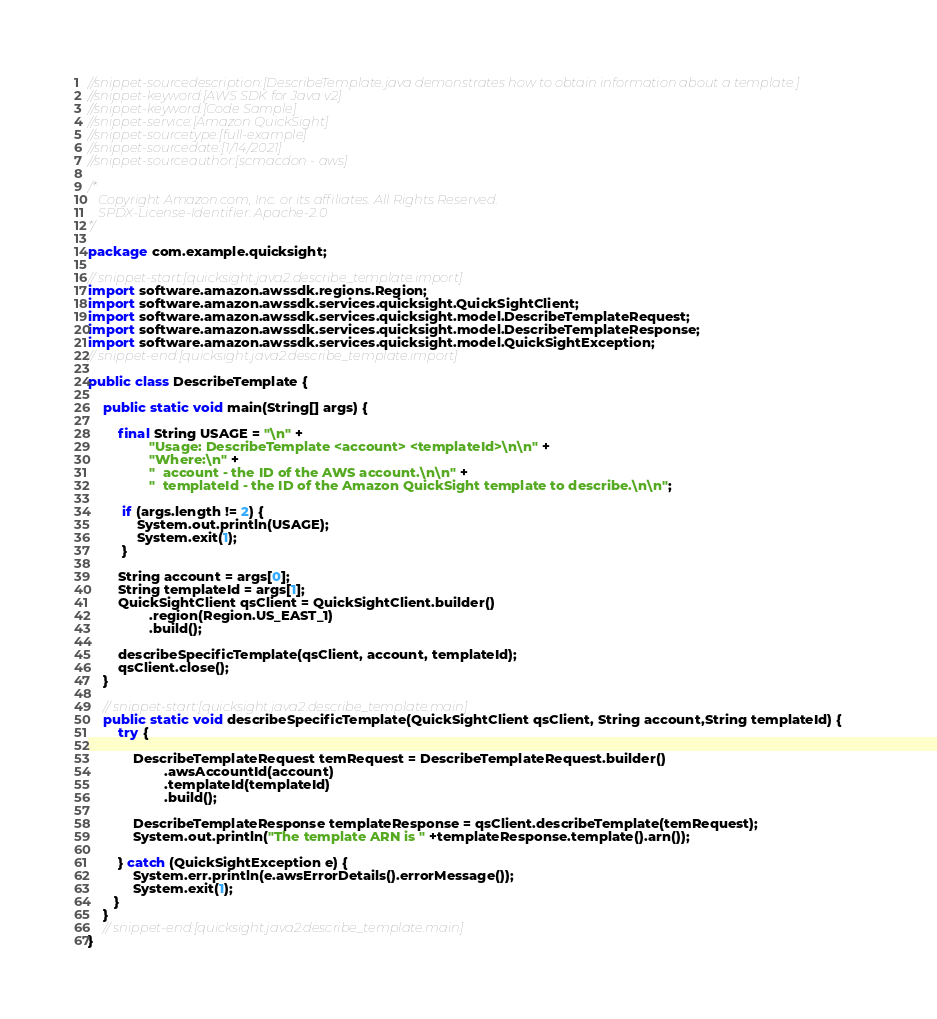<code> <loc_0><loc_0><loc_500><loc_500><_Java_>//snippet-sourcedescription:[DescribeTemplate.java demonstrates how to obtain information about a template.]
//snippet-keyword:[AWS SDK for Java v2]
//snippet-keyword:[Code Sample]
//snippet-service:[Amazon QuickSight]
//snippet-sourcetype:[full-example]
//snippet-sourcedate:[1/14/2021]
//snippet-sourceauthor:[scmacdon - aws]

/*
   Copyright Amazon.com, Inc. or its affiliates. All Rights Reserved.
   SPDX-License-Identifier: Apache-2.0
*/

package com.example.quicksight;

// snippet-start:[quicksight.java2.describe_template.import]
import software.amazon.awssdk.regions.Region;
import software.amazon.awssdk.services.quicksight.QuickSightClient;
import software.amazon.awssdk.services.quicksight.model.DescribeTemplateRequest;
import software.amazon.awssdk.services.quicksight.model.DescribeTemplateResponse;
import software.amazon.awssdk.services.quicksight.model.QuickSightException;
// snippet-end:[quicksight.java2.describe_template.import]

public class DescribeTemplate {

    public static void main(String[] args) {

        final String USAGE = "\n" +
                "Usage: DescribeTemplate <account> <templateId>\n\n" +
                "Where:\n" +
                "  account - the ID of the AWS account.\n\n" +
                "  templateId - the ID of the Amazon QuickSight template to describe.\n\n";

         if (args.length != 2) {
             System.out.println(USAGE);
             System.exit(1);
         }

        String account = args[0];
        String templateId = args[1];
        QuickSightClient qsClient = QuickSightClient.builder()
                .region(Region.US_EAST_1)
                .build();

        describeSpecificTemplate(qsClient, account, templateId);
        qsClient.close();
    }

    // snippet-start:[quicksight.java2.describe_template.main]
    public static void describeSpecificTemplate(QuickSightClient qsClient, String account,String templateId) {
        try {

            DescribeTemplateRequest temRequest = DescribeTemplateRequest.builder()
                    .awsAccountId(account)
                    .templateId(templateId)
                    .build();

            DescribeTemplateResponse templateResponse = qsClient.describeTemplate(temRequest);
            System.out.println("The template ARN is " +templateResponse.template().arn());

        } catch (QuickSightException e) {
            System.err.println(e.awsErrorDetails().errorMessage());
            System.exit(1);
       }
    }
    // snippet-end:[quicksight.java2.describe_template.main]
}


</code> 